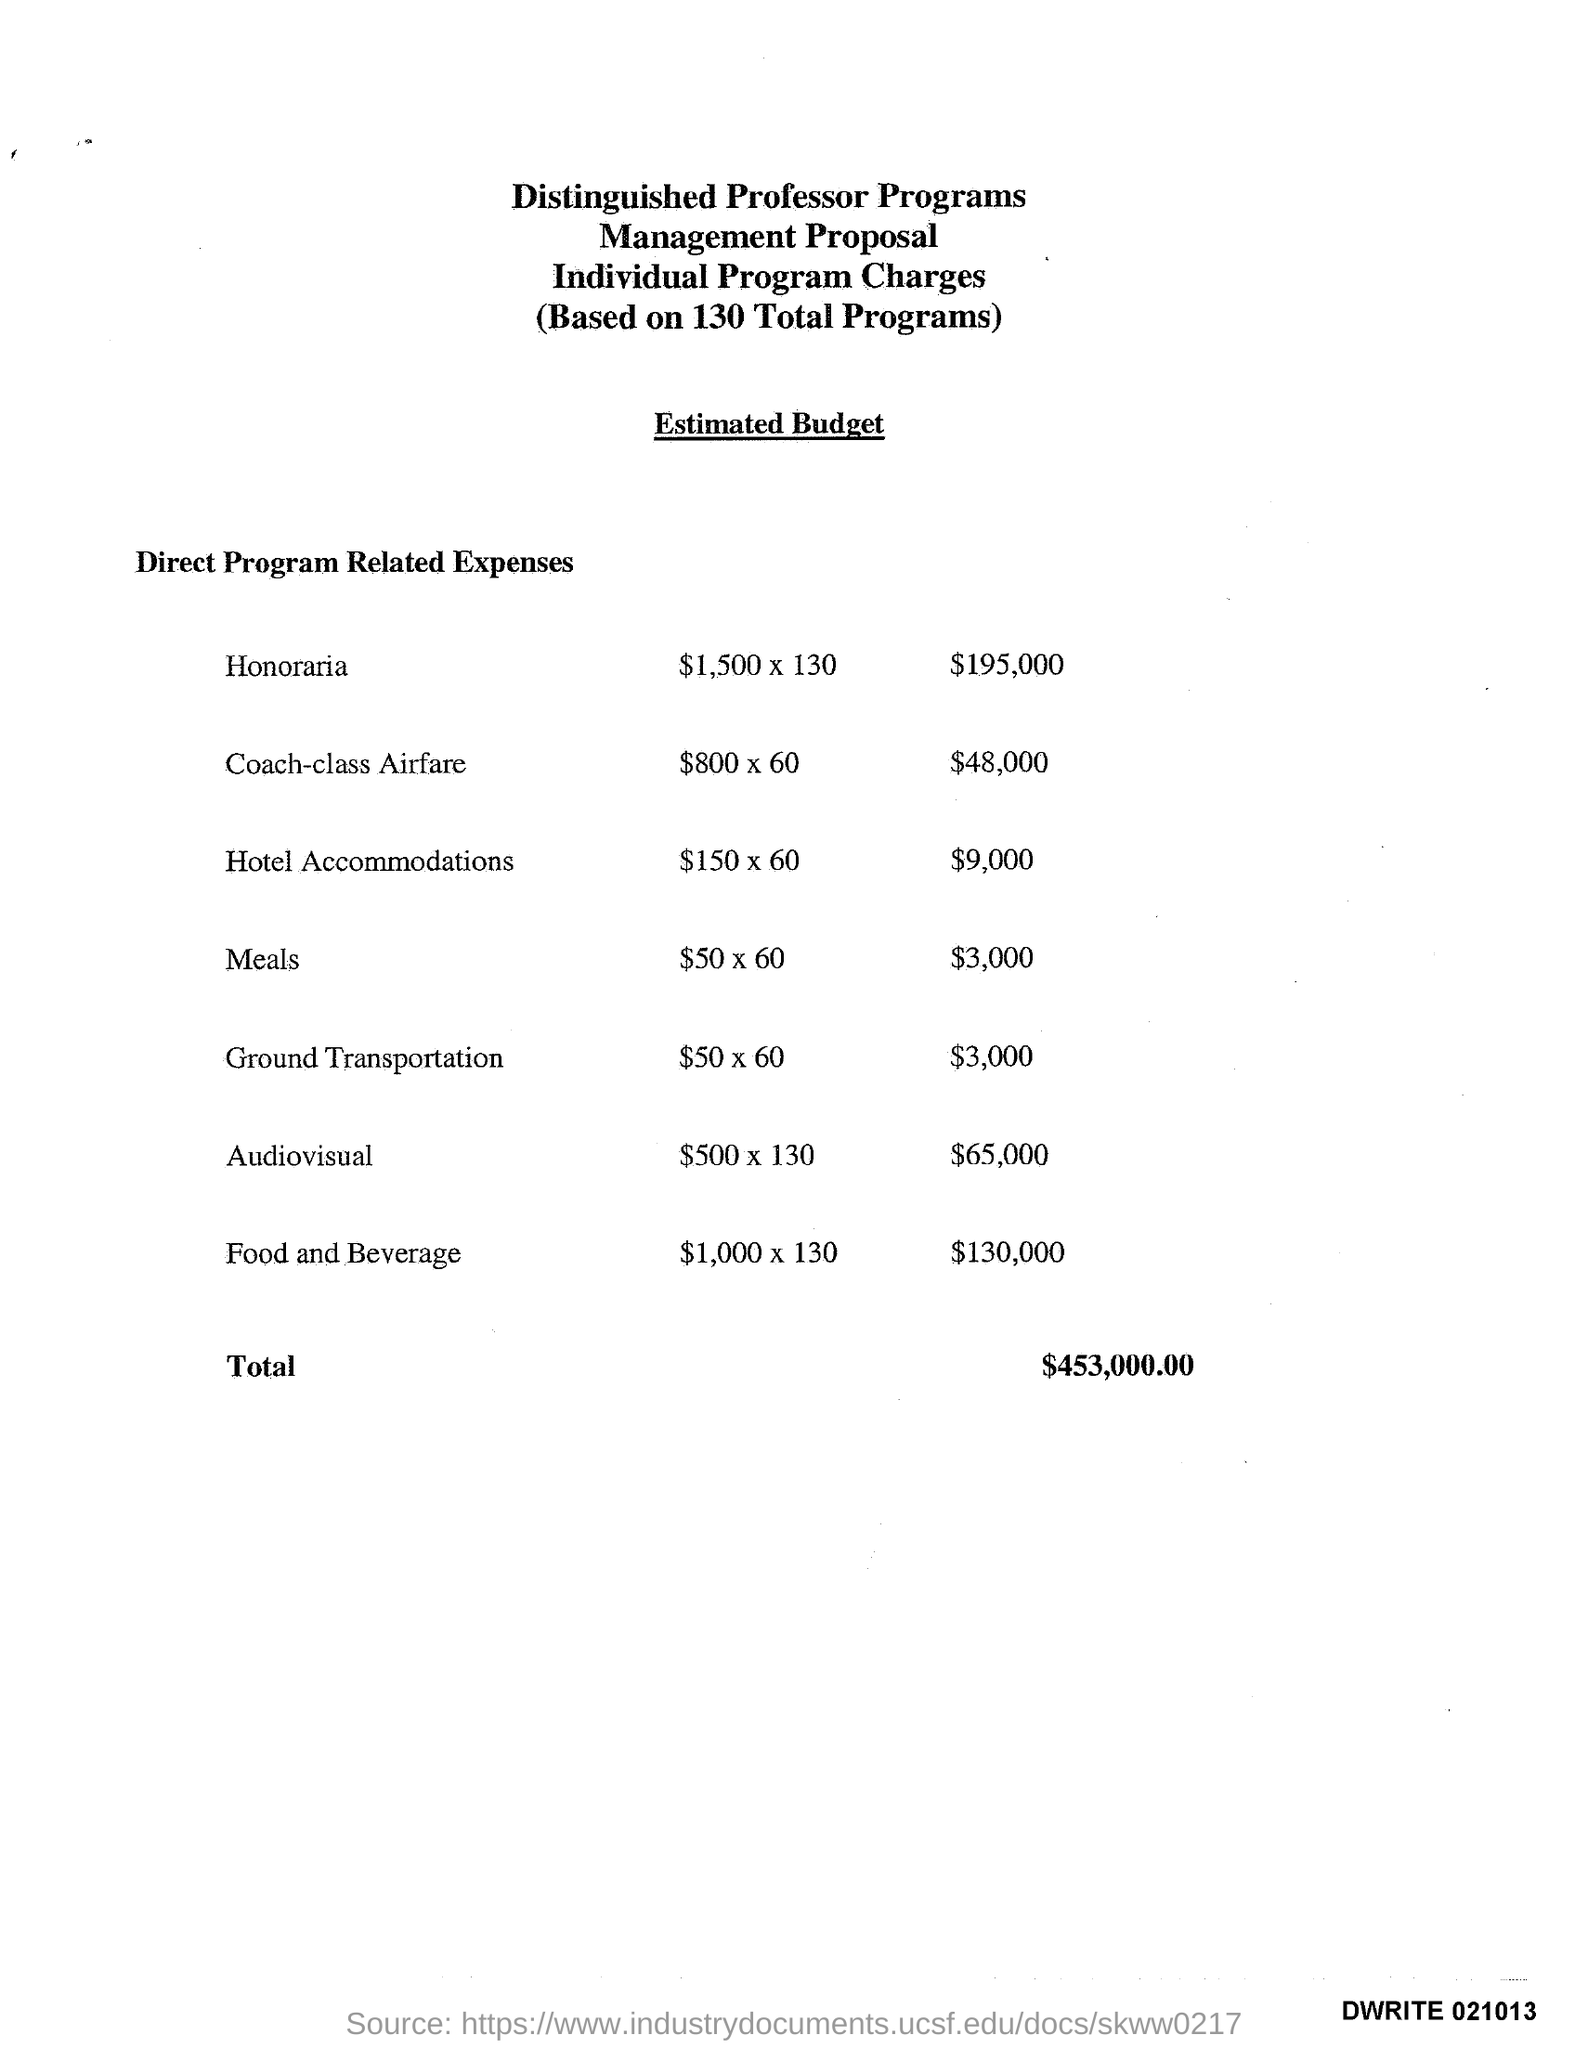Specify some key components in this picture. The program that spent $195,000 in honoraria is named. The least amount of expenses is $3,000. The total amount of expenses is $453,000.00. 